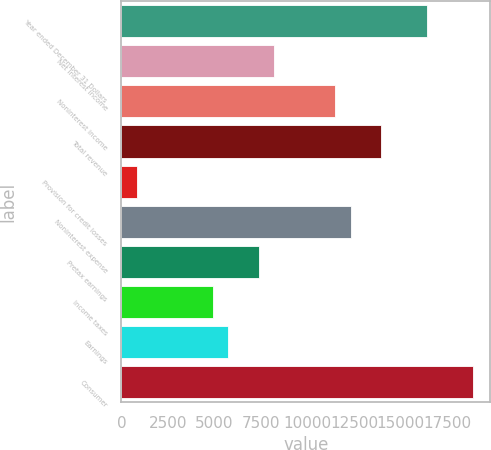Convert chart. <chart><loc_0><loc_0><loc_500><loc_500><bar_chart><fcel>Year ended December 31 Dollars<fcel>Net interest income<fcel>Noninterest income<fcel>Total revenue<fcel>Provision for credit losses<fcel>Noninterest expense<fcel>Pretax earnings<fcel>Income taxes<fcel>Earnings<fcel>Consumer<nl><fcel>16425.5<fcel>8214<fcel>11498.6<fcel>13962<fcel>823.65<fcel>12319.8<fcel>7392.85<fcel>4929.4<fcel>5750.55<fcel>18889<nl></chart> 